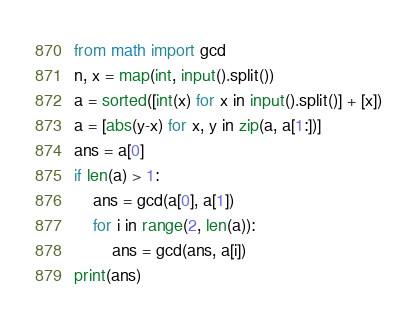Convert code to text. <code><loc_0><loc_0><loc_500><loc_500><_Python_>from math import gcd
n, x = map(int, input().split())
a = sorted([int(x) for x in input().split()] + [x])
a = [abs(y-x) for x, y in zip(a, a[1:])]
ans = a[0]
if len(a) > 1:
    ans = gcd(a[0], a[1])
    for i in range(2, len(a)): 
        ans = gcd(ans, a[i]) 
print(ans)</code> 